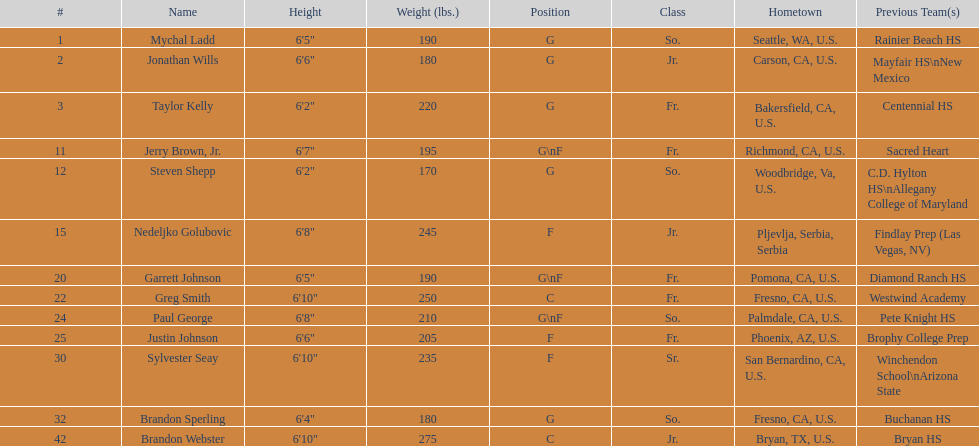Who is the only competitor not originating from the u.s.? Nedeljko Golubovic. 